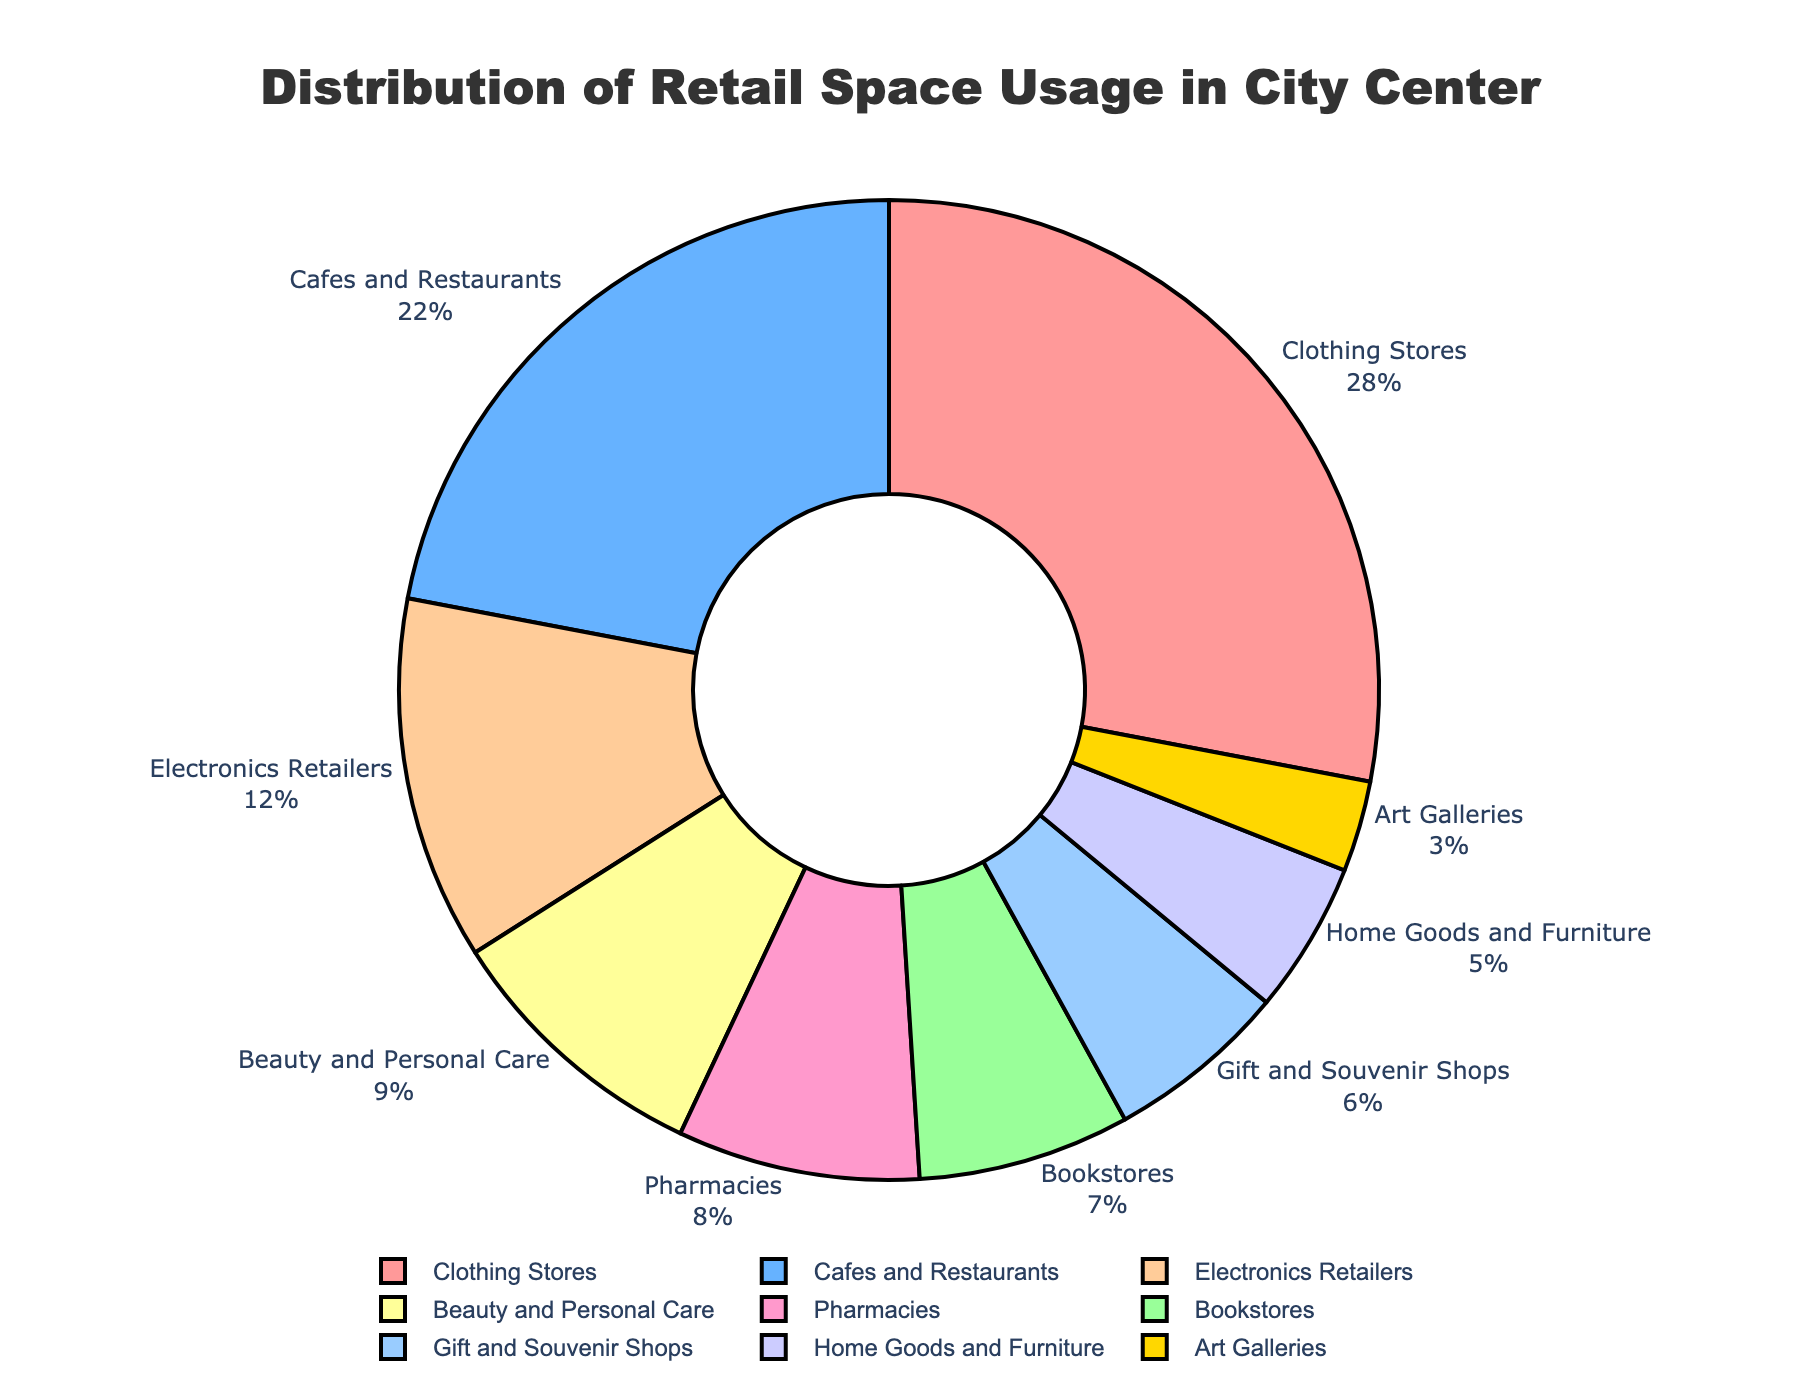what percentage of the retail space usage is taken up by bookstores? The figure shows the percentage values for each category. Just refer to the label for bookstores.
Answer: 7% Which category occupies the largest percentage of retail space? Look at the category that has the highest percentage in the figure.
Answer: Clothing Stores How much more space do cafes and restaurants take up than bookstores? Subtract the percentage of bookstores from the percentage of cafes and restaurants. 22% - 7% = 15%
Answer: 15% Are there more beauty and personal care stores or pharmacies? Compare the percentages of beauty and personal care stores and pharmacies. Beauty and Personal Care = 9%, Pharmacies = 8%.
Answer: Beauty and Personal Care What is the combined percentage of retail space taken up by cafes and restaurants and electronics retailers? Add the percentages of cafes and restaurants and electronics retailers. 22% + 12% = 34%
Answer: 34% Which category occupies less space: gift and souvenir shops or home goods and furniture? Compare the percentages of gift and souvenir shops and home goods and furniture. Gift and Souvenir Shops = 6%, Home Goods and Furniture = 5%.
Answer: Home Goods and Furniture What's the difference in retail space occupied by clothing stores and art galleries? Subtract the percentage of art galleries from the percentage of clothing stores. 28% - 3% = 25%
Answer: 25% What is the average percentage of retail space occupied by bookstores, electronics retailers, and pharmacies? Add the percentages of bookstores, electronics retailers, and pharmacies and divide by 3. (7% + 12% + 8%) / 3 = 9%
Answer: 9% Which category is represented by the blue color in the pie chart? Referring to the pie chart's colors and labels, the blue color corresponds to Cafes and Restaurants.
Answer: Cafes and Restaurants 